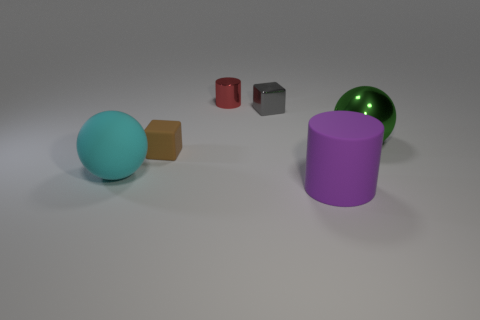Is there a gray metal cube on the right side of the gray metallic block to the left of the shiny sphere?
Your response must be concise. No. What number of small objects are yellow rubber cubes or shiny things?
Your answer should be very brief. 2. Is there a blue cylinder of the same size as the purple rubber cylinder?
Your answer should be very brief. No. What number of matte things are either cyan balls or purple objects?
Offer a very short reply. 2. What number of yellow shiny balls are there?
Ensure brevity in your answer.  0. Is the thing that is left of the brown rubber block made of the same material as the large sphere that is to the right of the brown matte cube?
Make the answer very short. No. What size is the cube that is made of the same material as the small cylinder?
Offer a very short reply. Small. There is a small shiny thing in front of the red thing; what is its shape?
Your response must be concise. Cube. Is the color of the cylinder that is on the right side of the tiny red cylinder the same as the tiny cube right of the tiny red shiny thing?
Offer a very short reply. No. Is there a yellow rubber cube?
Give a very brief answer. No. 